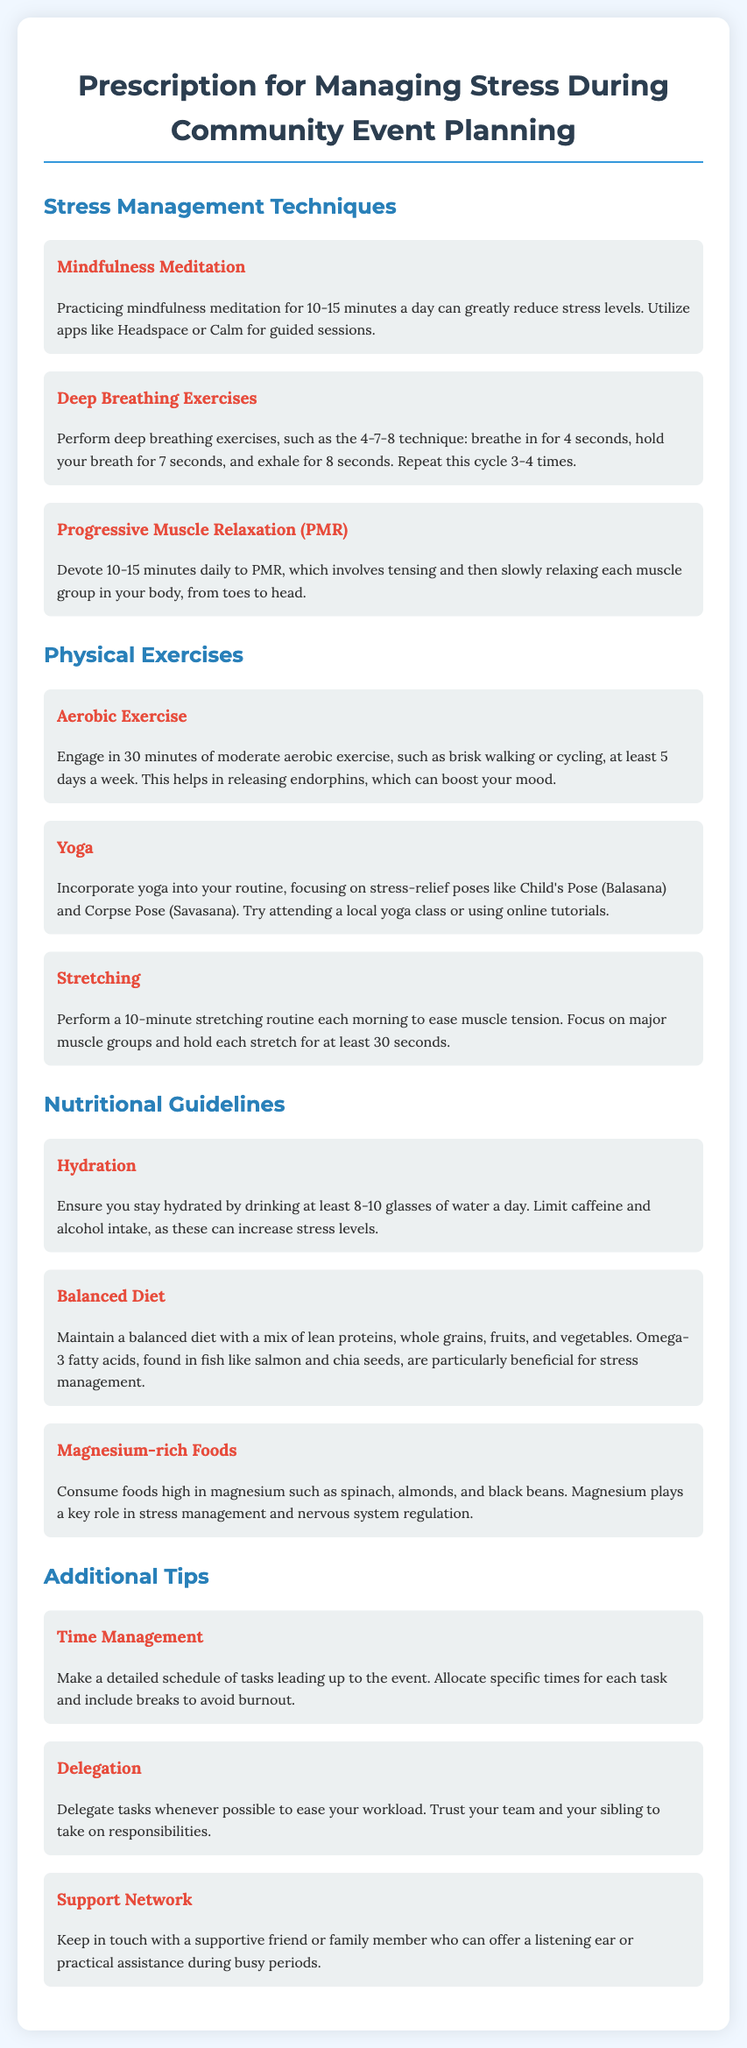What is the recommended duration for mindfulness meditation? The document states that practicing mindfulness meditation should be done for 10-15 minutes a day.
Answer: 10-15 minutes What technique is suggested for deep breathing exercises? The recommended technique is the 4-7-8 technique, which involves specific timing for breathing.
Answer: 4-7-8 technique How many days a week should one engage in moderate aerobic exercise? The document recommends engaging in aerobic exercise at least 5 days a week.
Answer: 5 days What is one of the key nutrients found in magnesium-rich foods? The document lists magnesium as a key nutrient that plays a role in stress management.
Answer: Magnesium What kind of exercises are recommended to be involved in the morning routine? The document suggests performing a 10-minute stretching routine each morning to ease muscle tension.
Answer: Stretching How does the document suggest managing time before the event? It advises making a detailed schedule of tasks leading up to the event, including specific times for each task and breaks.
Answer: Detailed schedule What is one of the additional tips for stress management mentioned in the document? The document includes delegating tasks whenever possible to ease the workload as a tip.
Answer: Delegation What is one type of exercise mentioned that focuses on stress relief? The document mentions yoga as a type of exercise that focuses on stress relief.
Answer: Yoga 